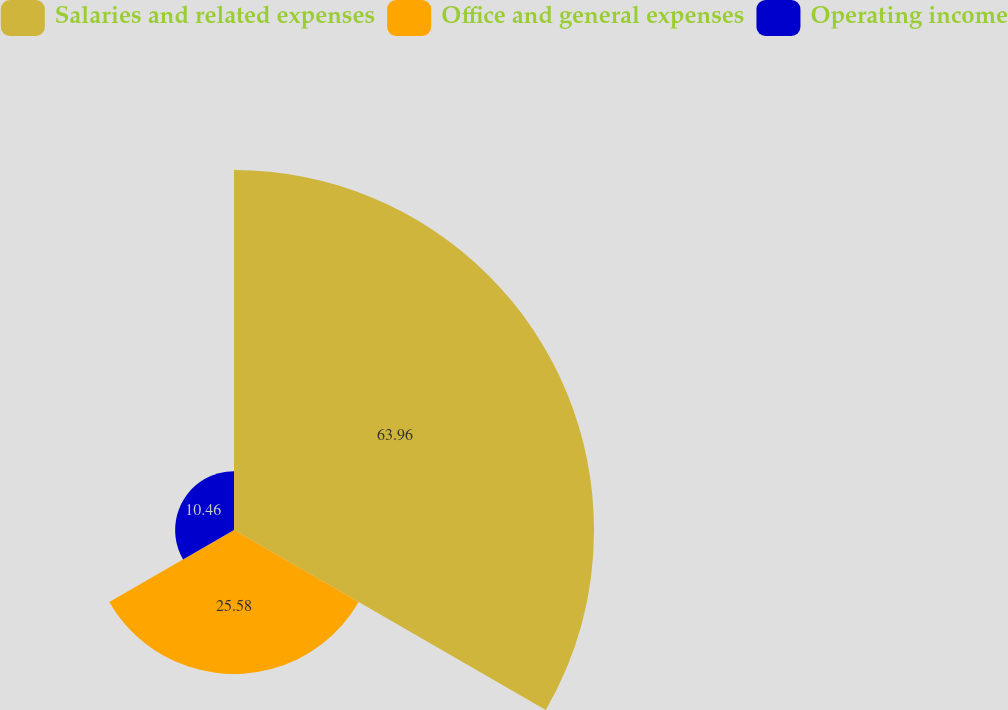Convert chart to OTSL. <chart><loc_0><loc_0><loc_500><loc_500><pie_chart><fcel>Salaries and related expenses<fcel>Office and general expenses<fcel>Operating income<nl><fcel>63.96%<fcel>25.58%<fcel>10.46%<nl></chart> 